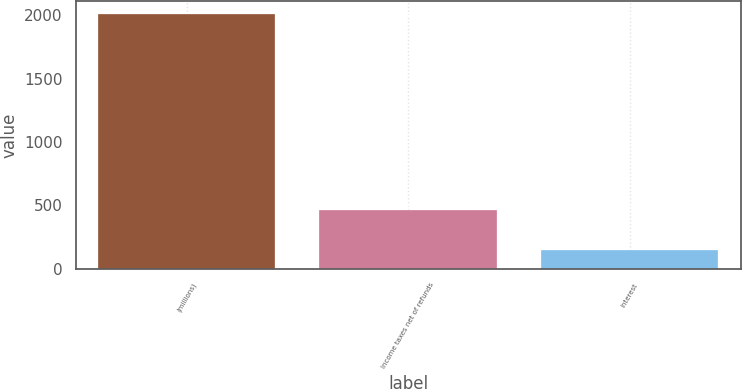<chart> <loc_0><loc_0><loc_500><loc_500><bar_chart><fcel>(millions)<fcel>Income taxes net of refunds<fcel>Interest<nl><fcel>2009<fcel>461.7<fcel>144.7<nl></chart> 